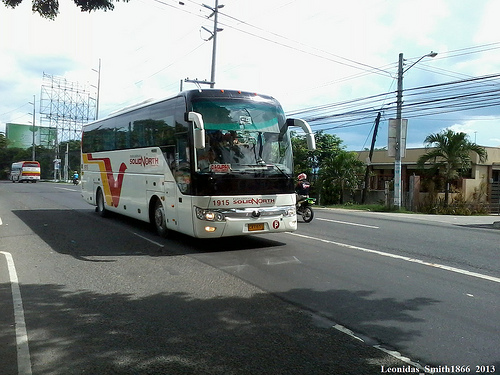In a longer response, describe a day in the life of the bus driver. The bus driver, let's call him John, starts his day early in the morning. He prepares for the day ahead by checking the bus's condition, ensuring everything is in good working order. With a quick breakfast, he sets off from the bus depot, greeting the familiar faces of regular passengers with a smile. His route takes him through bustling city streets, where he deftly navigates through the traffic. He takes pride in knowing the intricacies of his route, from the busiest intersections to the quietest corners. During rush hour, the bus fills up with commuters, and John remains focused, alert to the road and his passengers' safety. At designated bus stops, he assists elderly passengers and ensures that everyone is safely on board. Lunchtime offers him a brief respite, where he enjoys a packed lunch before starting his afternoon route. Throughout the day, he hears snippets of conversations and watches as the city moves around him. By evening, as he completes his final route and returns the bus to the depot, he feels satisfied with his day's work, knowing he played an important part in the daily lives of many. He heads home, ready to do it all again the next day. 